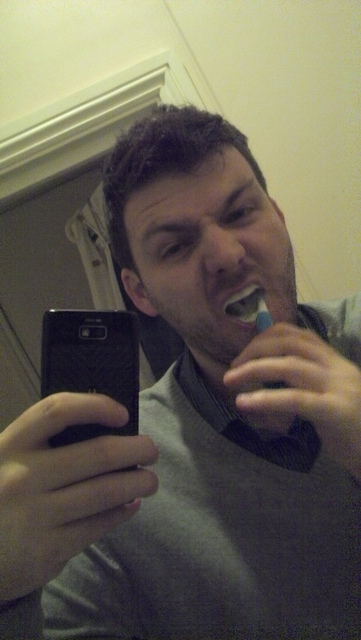<image>Is this man trying to be funny? I don't know if the man is trying to be funny or not. It can be seen both ways. What game system is he playing? I am not sure what game system he is playing, it can be mobile, apple or android. What color is the giraffe's tongue? There is no giraffe in the image. What color is the man's necktie? The man does not appear to be wearing a necktie. However, if there is a necktie, it could be black. What is the level the man is holding with his thumb called? It is unknown what the level the man is holding with his thumb is called. It could be a button, smartphone, selfie or even a toothbrush. Is this man trying to be funny? I don't know if this man is trying to be funny. It can go either way. What game system is he playing? I don't know what game system he is playing. It can be either mobile, smartphone or video games. What color is the giraffe's tongue? There is no giraffe in the picture. What color is the man's necktie? The man in the image is not wearing a necktie. What is the level the man is holding with his thumb called? I don't know what the level the man is holding with his thumb is called. 